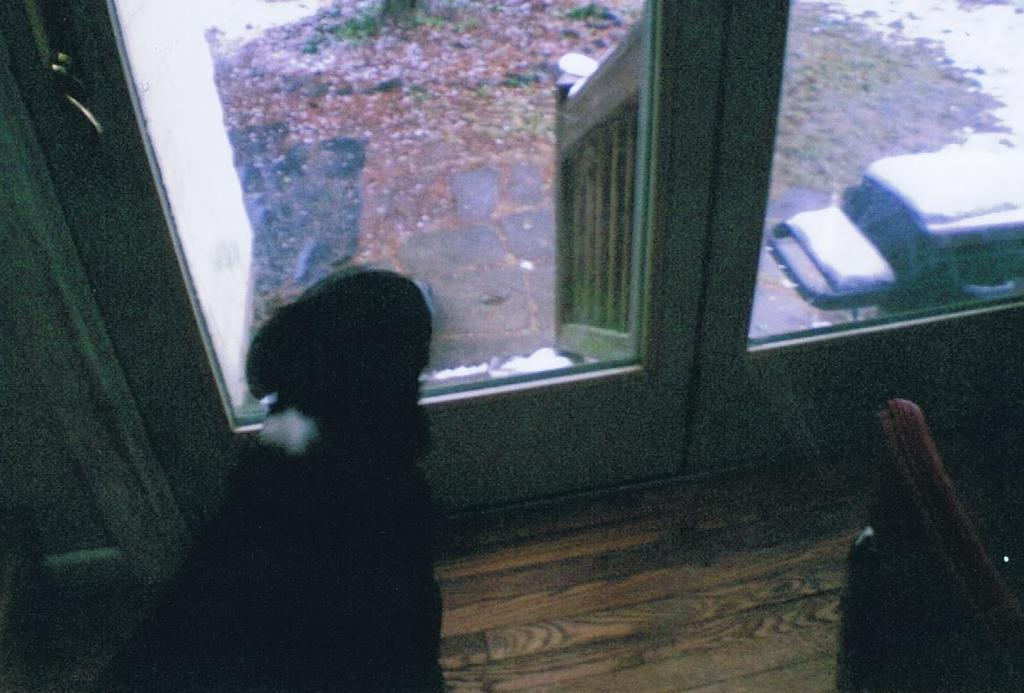What is one of the main features of the image? There is a door in the image. What can be seen outside the door? There is a vehicle outside the door. What is the weather like in the image? Snow is present around the house, indicating a cold or wintry weather condition. Can you describe the facial expression of the person holding the receipt in the image? There is no person holding a receipt in the image, as the facts provided do not mention any person or receipt. 